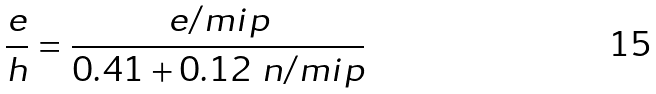<formula> <loc_0><loc_0><loc_500><loc_500>\frac { e } { h } = \frac { e / m i p } { 0 . 4 1 + 0 . 1 2 \ n / m i p }</formula> 